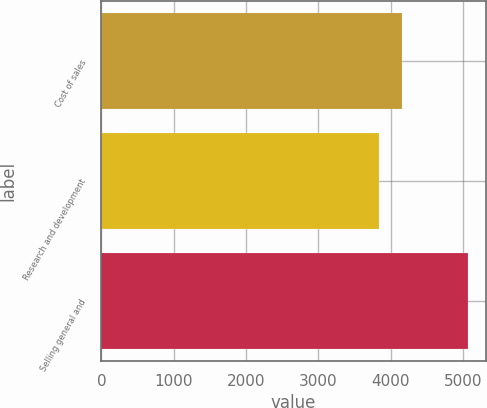Convert chart. <chart><loc_0><loc_0><loc_500><loc_500><bar_chart><fcel>Cost of sales<fcel>Research and development<fcel>Selling general and<nl><fcel>4162<fcel>3840<fcel>5062<nl></chart> 